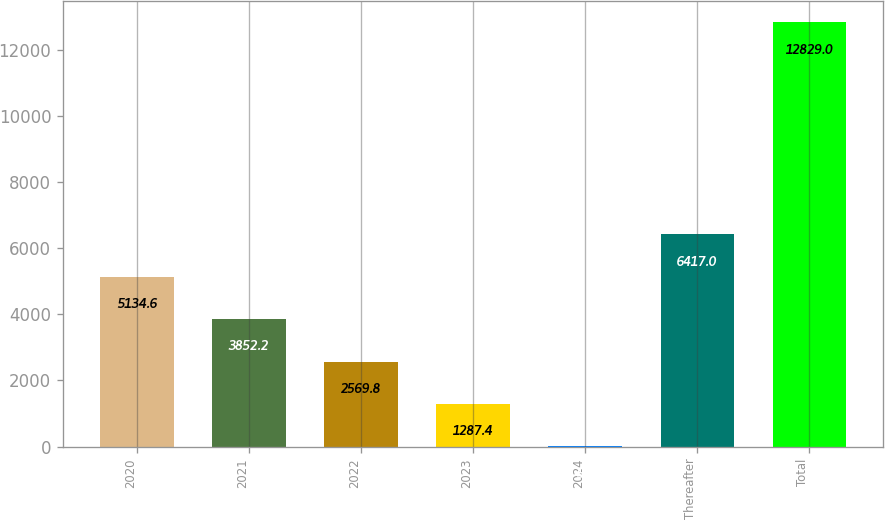Convert chart. <chart><loc_0><loc_0><loc_500><loc_500><bar_chart><fcel>2020<fcel>2021<fcel>2022<fcel>2023<fcel>2024<fcel>Thereafter<fcel>Total<nl><fcel>5134.6<fcel>3852.2<fcel>2569.8<fcel>1287.4<fcel>5<fcel>6417<fcel>12829<nl></chart> 